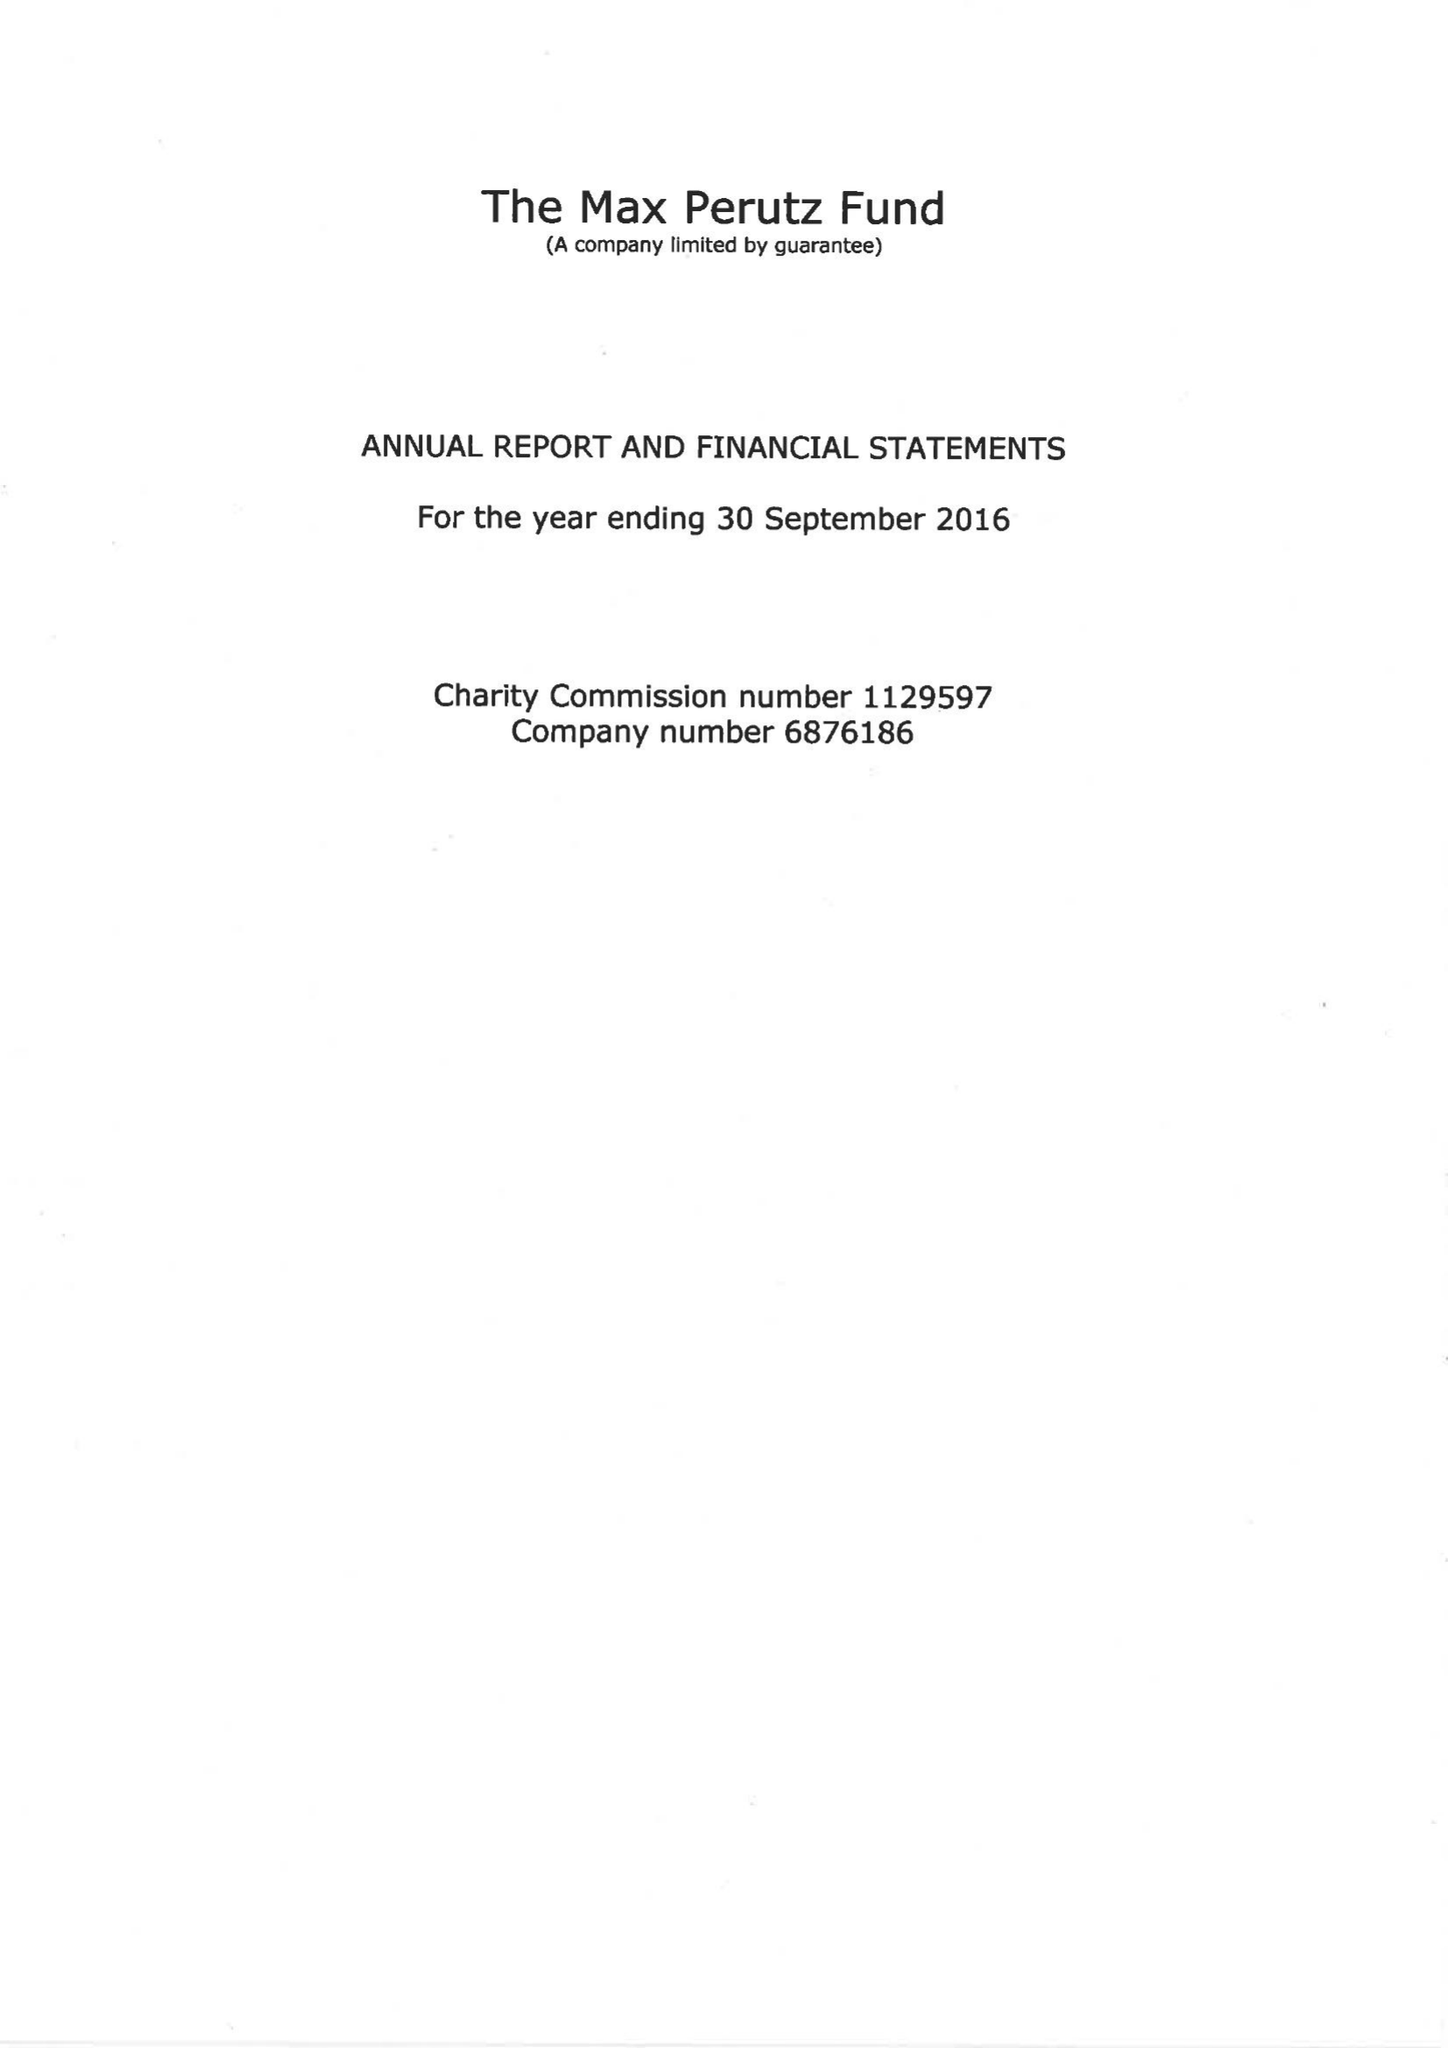What is the value for the charity_number?
Answer the question using a single word or phrase. 1129597 